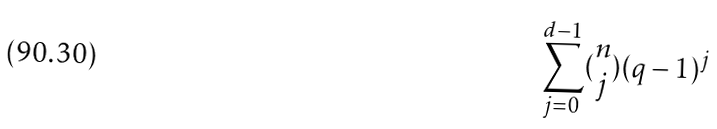Convert formula to latex. <formula><loc_0><loc_0><loc_500><loc_500>\sum _ { j = 0 } ^ { d - 1 } ( \begin{matrix} n \\ j \end{matrix} ) ( q - 1 ) ^ { j }</formula> 